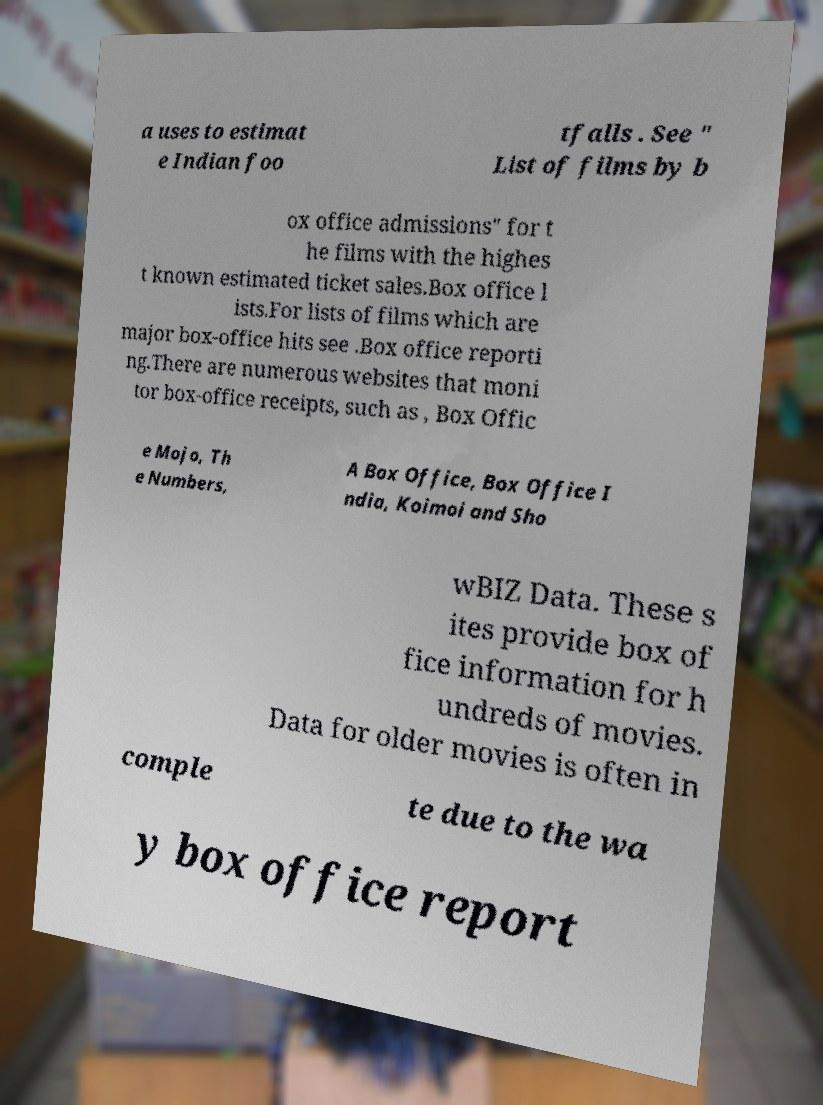Can you read and provide the text displayed in the image?This photo seems to have some interesting text. Can you extract and type it out for me? a uses to estimat e Indian foo tfalls . See " List of films by b ox office admissions" for t he films with the highes t known estimated ticket sales.Box office l ists.For lists of films which are major box-office hits see .Box office reporti ng.There are numerous websites that moni tor box-office receipts, such as , Box Offic e Mojo, Th e Numbers, A Box Office, Box Office I ndia, Koimoi and Sho wBIZ Data. These s ites provide box of fice information for h undreds of movies. Data for older movies is often in comple te due to the wa y box office report 